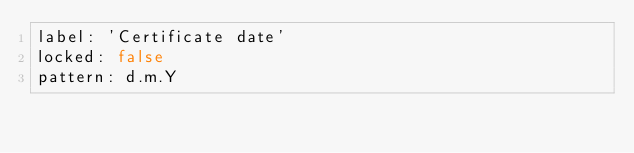<code> <loc_0><loc_0><loc_500><loc_500><_YAML_>label: 'Certificate date'
locked: false
pattern: d.m.Y
</code> 